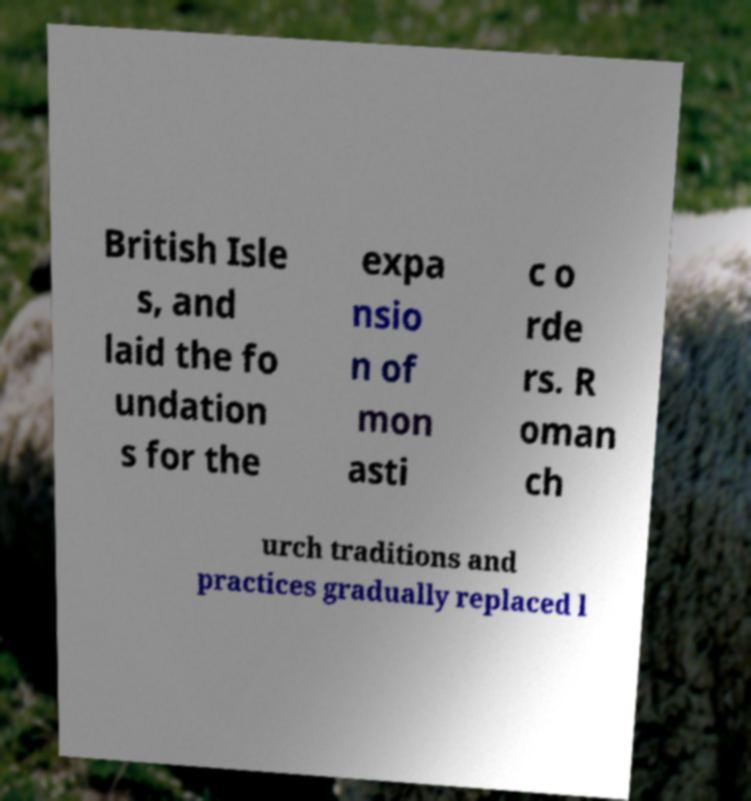Could you extract and type out the text from this image? British Isle s, and laid the fo undation s for the expa nsio n of mon asti c o rde rs. R oman ch urch traditions and practices gradually replaced l 